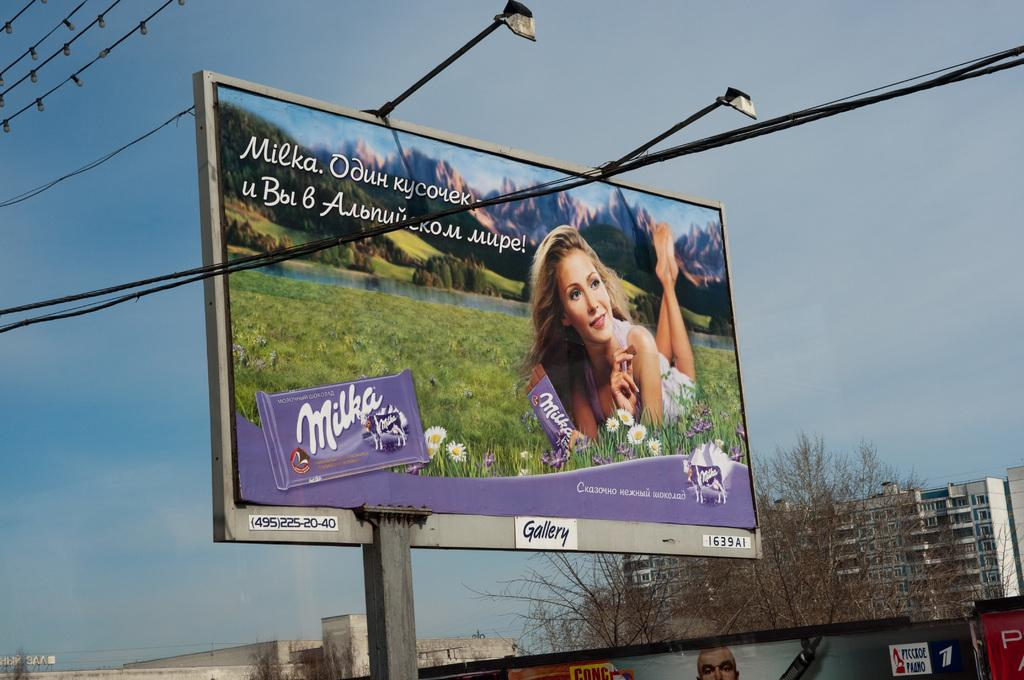Provide a one-sentence caption for the provided image. A giant billboard featuring a woman holding a Milka chocolate bar. 